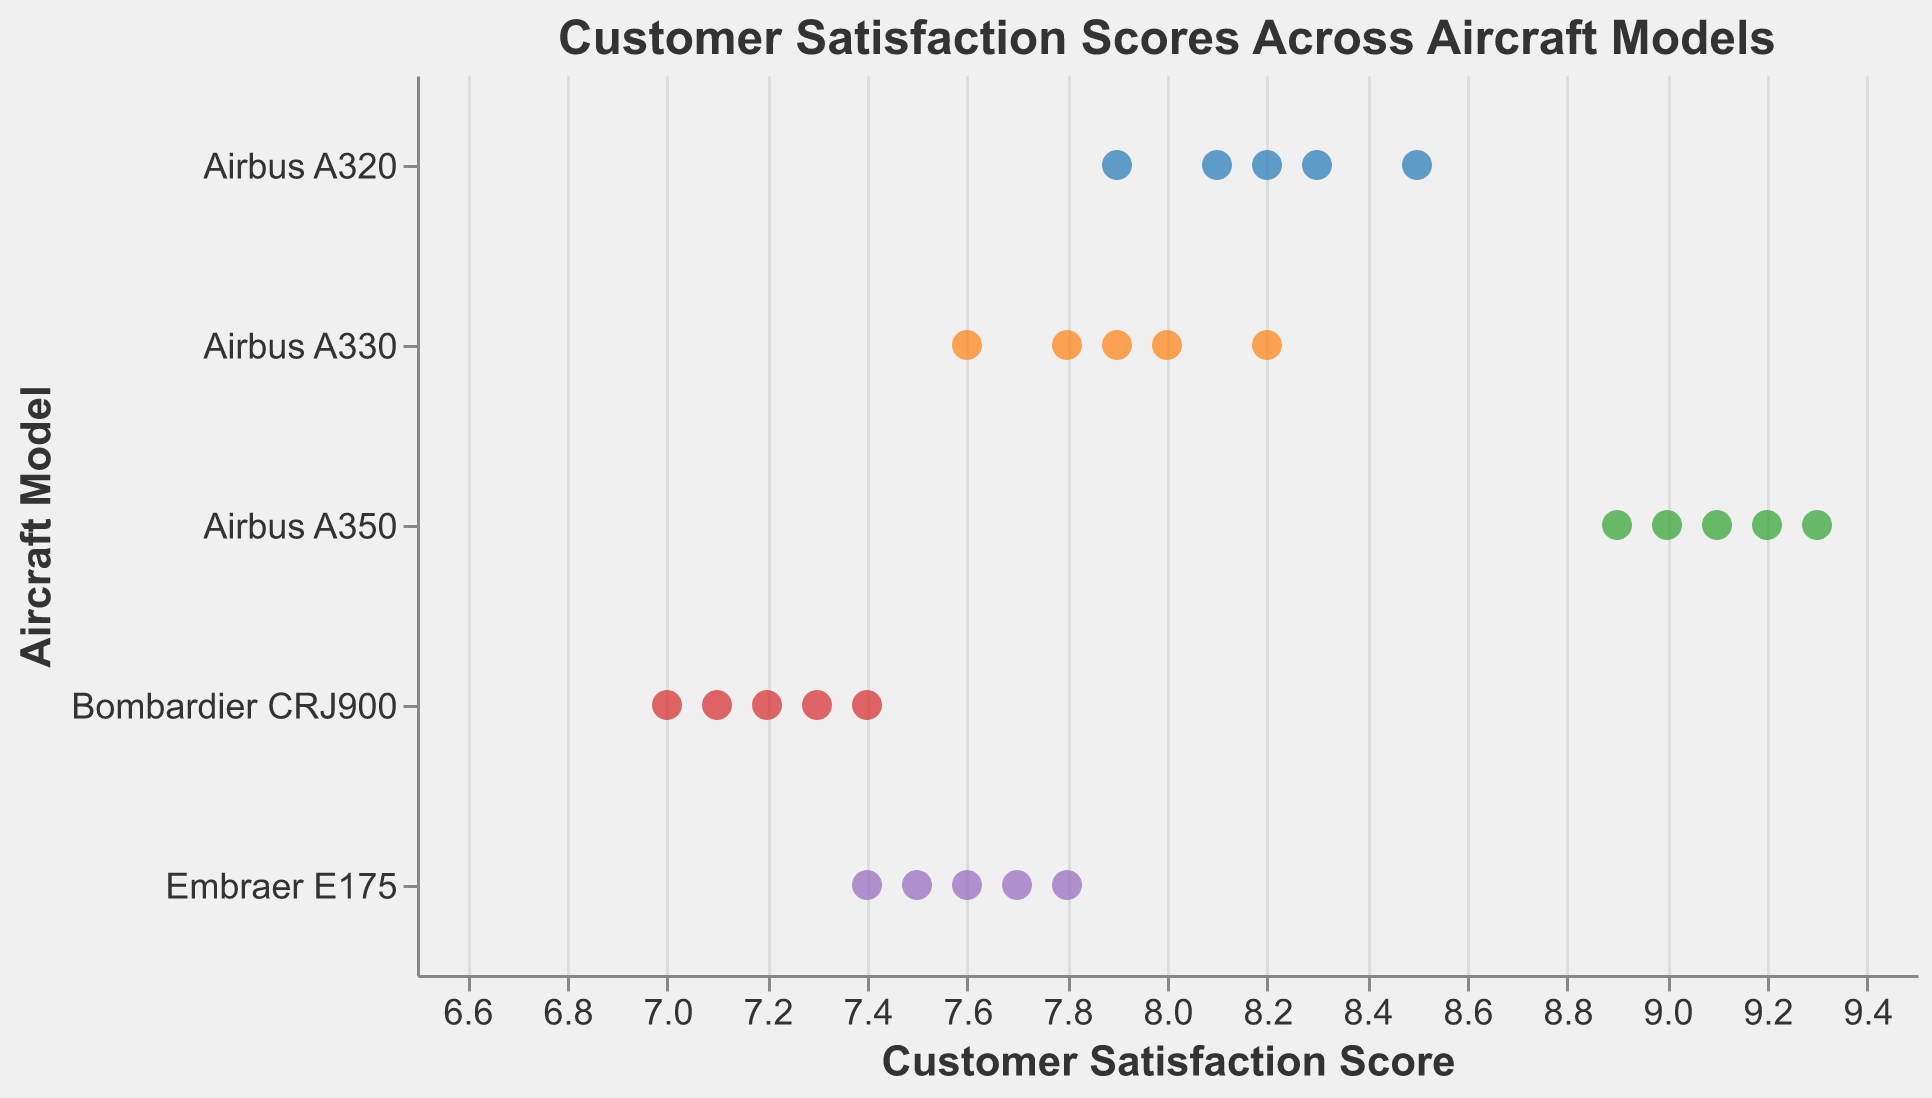What is the title of the figure? The title of the figure can be seen at the top of the plot. It reads "Customer Satisfaction Scores Across Aircraft Models".
Answer: Customer Satisfaction Scores Across Aircraft Models Which aircraft model has the highest customer satisfaction score? By looking at the strip plot, the highest score under the x-axis of Customer Satisfaction Score corresponds to the Airbus A350 with a score of 9.3.
Answer: Airbus A350 How many data points are there for the Bombardier CRJ900 model? We can count the number of points aligned horizontally with the y-axis label "Bombardier CRJ900". There are 5 points.
Answer: 5 What is the range of customer satisfaction scores for the Embraer E175 model? By observing the points aligned horizontally with the y-axis label "Embraer E175", the minimum score is 7.4 and the maximum score is 7.8, giving a range of 7.4 to 7.8.
Answer: 7.4 to 7.8 Which aircraft model has the smallest variation in customer satisfaction scores? The variation of scores can be observed by the spread of points in each aircraft model. The points for Airbus A350 are very close to each other, indicating the smallest variation.
Answer: Airbus A350 What is the average customer satisfaction score for the Airbus A320? The average is computed by summing the scores for Airbus A320 and dividing by the number of data points. (8.2 + 7.9 + 8.5 + 8.1 + 8.3) / 5 = 41 / 5 = 8.2
Answer: 8.2 Which aircraft model has the lowest individual customer satisfaction score recorded? We observe the minimum dot aligned horizontally towards the lowest end of the x-axis. The lowest recorded score is 7.0 for Bombardier CRJ900.
Answer: Bombardier CRJ900 Among Airbus A320, Airbus A330, and Airbus A350, which model has the highest average customer satisfaction score? Calculate the average for each model and compare them:
- Airbus A320: (8.2 + 7.9 + 8.5 + 8.1 + 8.3) / 5 = 8.2
- Airbus A330: (7.8 + 8.0 + 7.6 + 8.2 + 7.9) / 5 = 7.9
- Airbus A350: (9.1 + 8.9 + 9.2 + 9.0 + 9.3) / 5 = 9.1
Airbus A350 has the highest average.
Answer: Airbus A350 What is the median customer satisfaction score for the Bombardier CRJ900 model? The median is the middle score when arranged in order. For Bombardier CRJ900, the scores are 7.0, 7.1, 7.2, 7.3, 7.4. The median is 7.2.
Answer: 7.2 